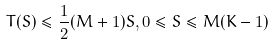Convert formula to latex. <formula><loc_0><loc_0><loc_500><loc_500>T ( S ) \leq \frac { 1 } { 2 } ( M + 1 ) S , 0 \leq S \leq M ( K - 1 )</formula> 